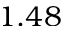Convert formula to latex. <formula><loc_0><loc_0><loc_500><loc_500>1 . 4 8</formula> 